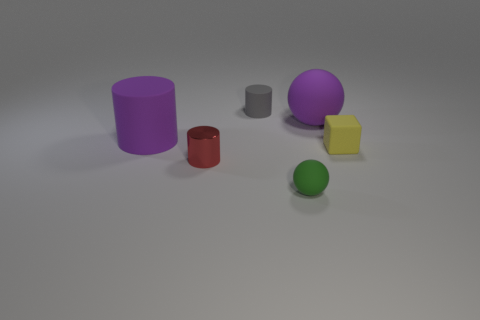Are there any other things that are the same shape as the yellow object?
Give a very brief answer. No. Is the number of small red objects that are on the left side of the purple ball greater than the number of tiny metal cylinders that are on the right side of the small red cylinder?
Give a very brief answer. Yes. There is a rubber object that is to the left of the tiny matte object that is behind the big purple object that is left of the small sphere; what size is it?
Ensure brevity in your answer.  Large. Is the large cylinder made of the same material as the tiny thing that is to the right of the big sphere?
Keep it short and to the point. Yes. Is the shape of the green matte thing the same as the yellow matte object?
Keep it short and to the point. No. What number of other objects are the same material as the red thing?
Offer a very short reply. 0. How many other tiny green things are the same shape as the green rubber thing?
Give a very brief answer. 0. There is a object that is both in front of the tiny yellow object and to the right of the tiny metal cylinder; what is its color?
Your answer should be compact. Green. What number of small brown shiny cubes are there?
Your answer should be very brief. 0. Do the green object and the red object have the same size?
Provide a short and direct response. Yes. 